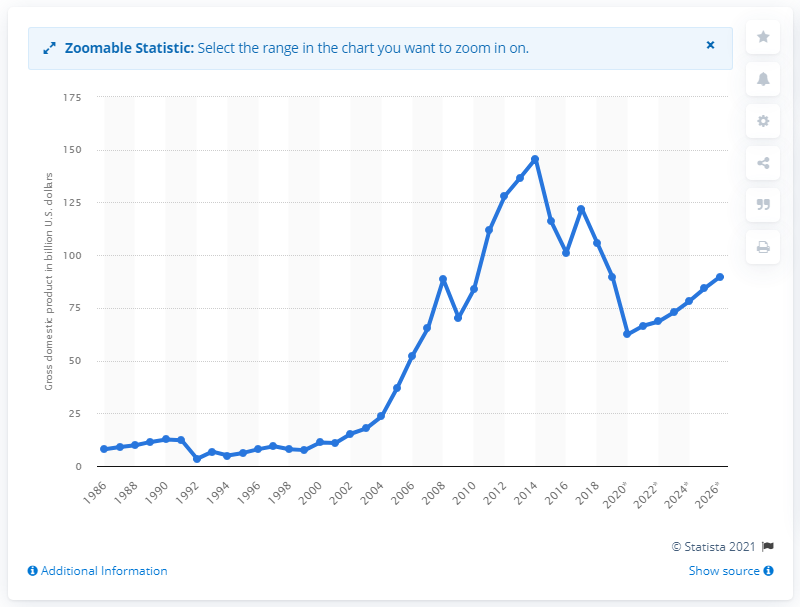Outline some significant characteristics in this image. In 2019, the Gross Domestic Product (GDP) of Angola was 89.82. 